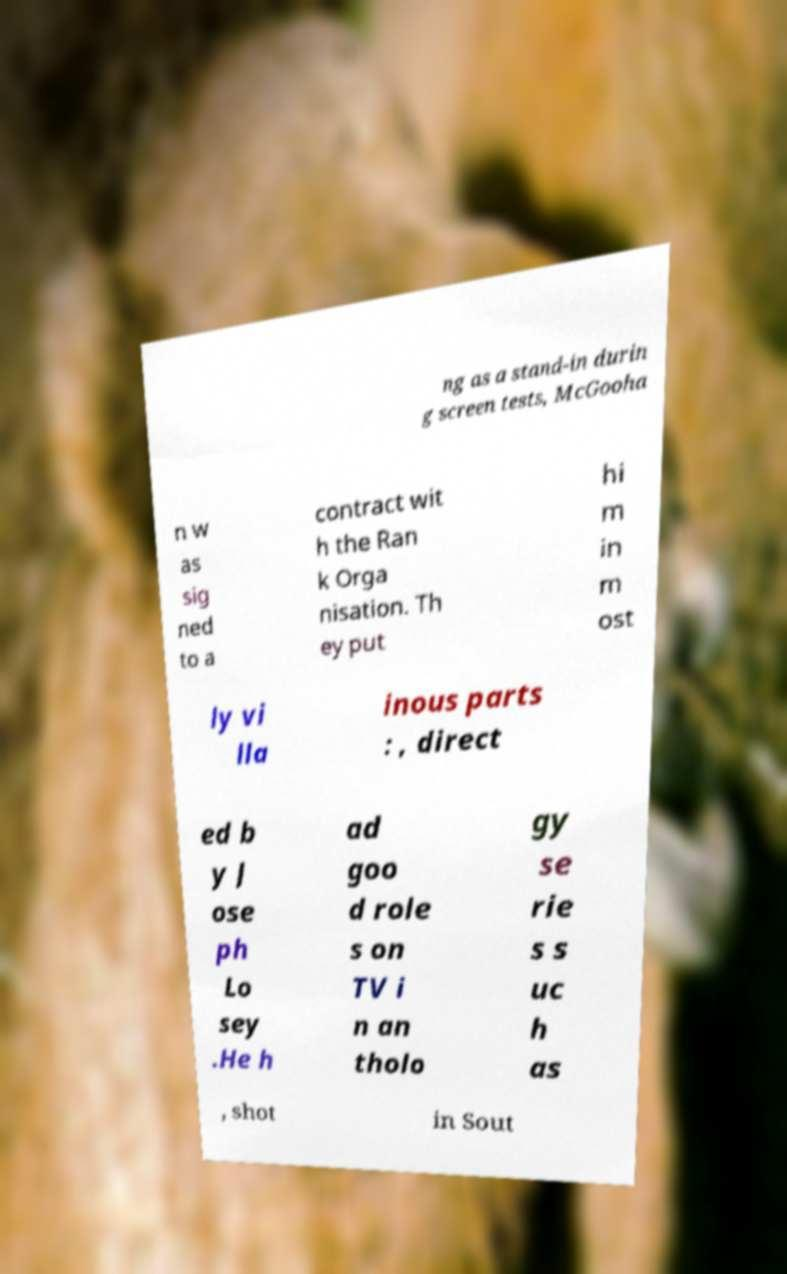Can you accurately transcribe the text from the provided image for me? ng as a stand-in durin g screen tests, McGooha n w as sig ned to a contract wit h the Ran k Orga nisation. Th ey put hi m in m ost ly vi lla inous parts : , direct ed b y J ose ph Lo sey .He h ad goo d role s on TV i n an tholo gy se rie s s uc h as , shot in Sout 